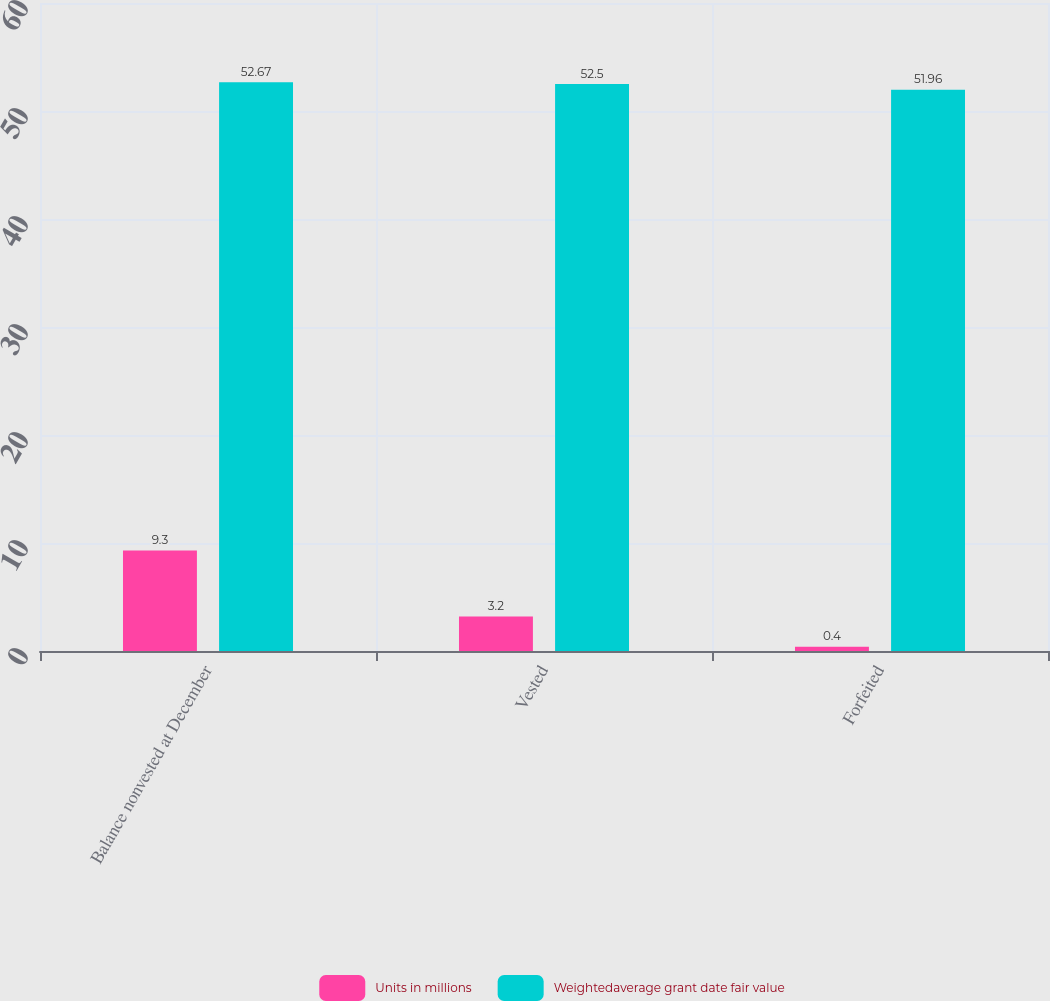Convert chart. <chart><loc_0><loc_0><loc_500><loc_500><stacked_bar_chart><ecel><fcel>Balance nonvested at December<fcel>Vested<fcel>Forfeited<nl><fcel>Units in millions<fcel>9.3<fcel>3.2<fcel>0.4<nl><fcel>Weightedaverage grant date fair value<fcel>52.67<fcel>52.5<fcel>51.96<nl></chart> 